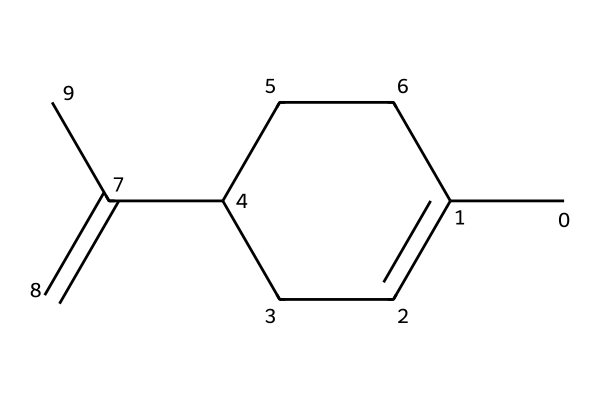What is the main function of limonene in insect repellents? Limonene is a natural insect repellent, which means it helps to keep insects away due to its strong odor. This property is linked to its hydrophobic structure, which allows it to act on the insect’s sensory receptors.
Answer: insect repellent How many carbon atoms are in limonene? By analyzing the SMILES representation, we count the carbon atoms indicated by the “C” and find a total of ten carbon atoms in the structure.
Answer: ten What type of bonding is primarily present in limonene? The bonding in limonene mainly consists of carbon-carbon single bonds and carbon-carbon double bonds, indicative of aliphatic compounds that have saturated and unsaturated regions.
Answer: single and double bonds What is the primary functional group in limonene? Limonene is classified as a cyclic monoterpene with a characteristic double bond, which indicates the presence of an alkene functional group.
Answer: alkene Is limonene polar or nonpolar? The majority of limonene's structure is composed of carbon and hydrogen, resulting in a nonpolar molecule, as it does not have significant electronegative elements that would create a polar bond.
Answer: nonpolar 